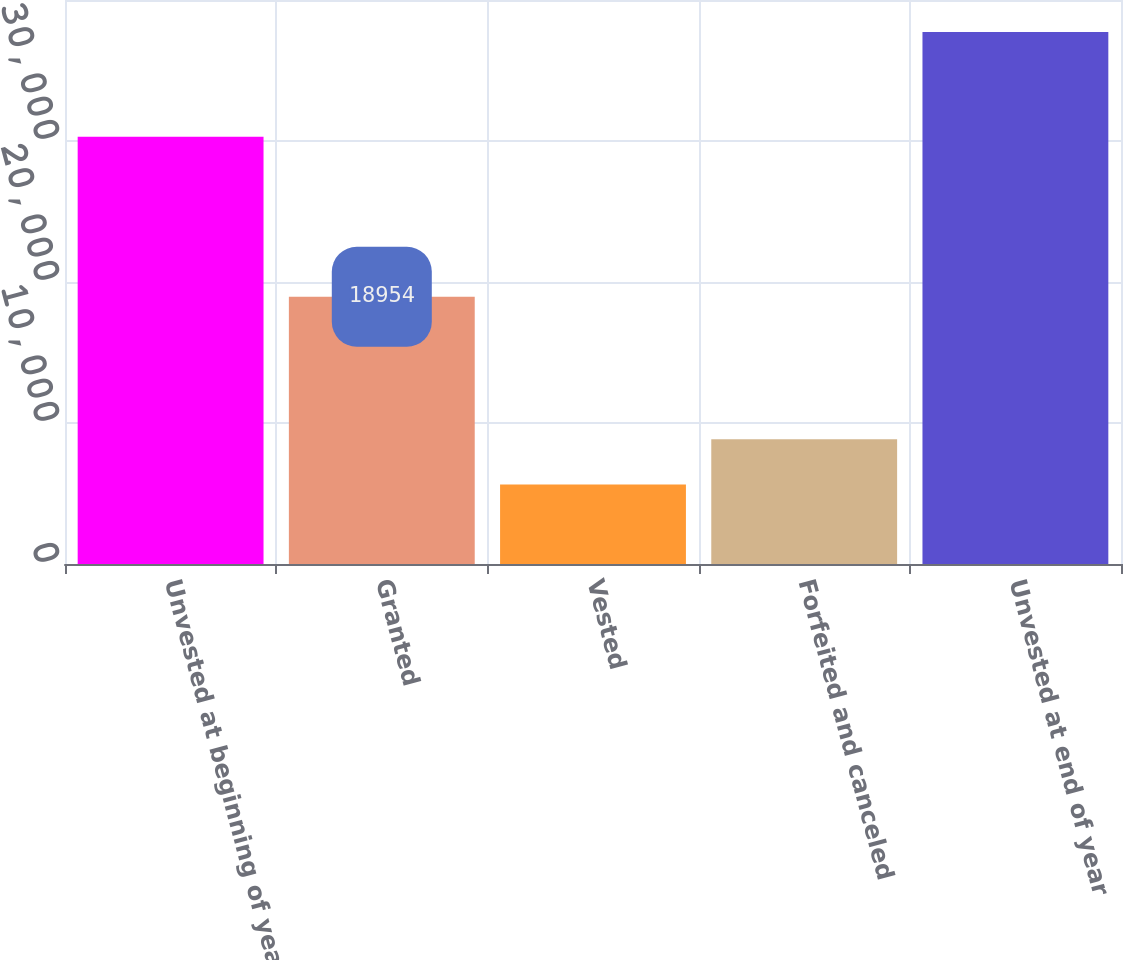<chart> <loc_0><loc_0><loc_500><loc_500><bar_chart><fcel>Unvested at beginning of year<fcel>Granted<fcel>Vested<fcel>Forfeited and canceled<fcel>Unvested at end of year<nl><fcel>30304<fcel>18954<fcel>5647<fcel>8855<fcel>37727<nl></chart> 